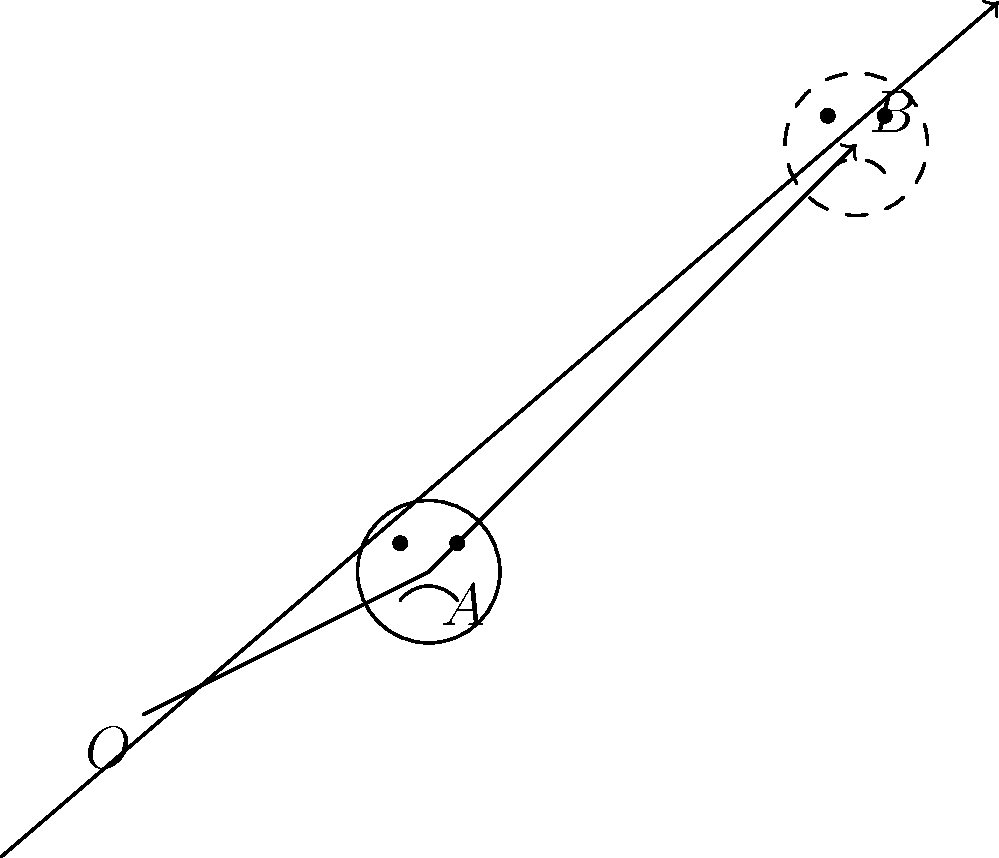Your sarcastic emoji face is feeling adventurous and decides to go on a journey along vector $\vec{v} = \langle 3, 3 \rangle$. If the center of the emoji is initially at point $A(2, 1)$, where will it end up after this translation? Express your answer as the coordinates of point $B$. Let's approach this step-by-step:

1) The translation of a point by a vector is achieved by adding the components of the vector to the coordinates of the point.

2) We are given:
   - Initial point $A(2, 1)$
   - Translation vector $\vec{v} = \langle 3, 3 \rangle$

3) To find the new location (point $B$), we add the components of $\vec{v}$ to the coordinates of $A$:

   $B_x = A_x + v_x = 2 + 3 = 5$
   $B_y = A_y + v_y = 1 + 3 = 4$

4) Therefore, the new location of the emoji's center after translation is the point $B(5, 4)$.

This translation moves the emoji diagonally up and to the right, maintaining its sarcastic expression but in a new location.
Answer: $B(5, 4)$ 